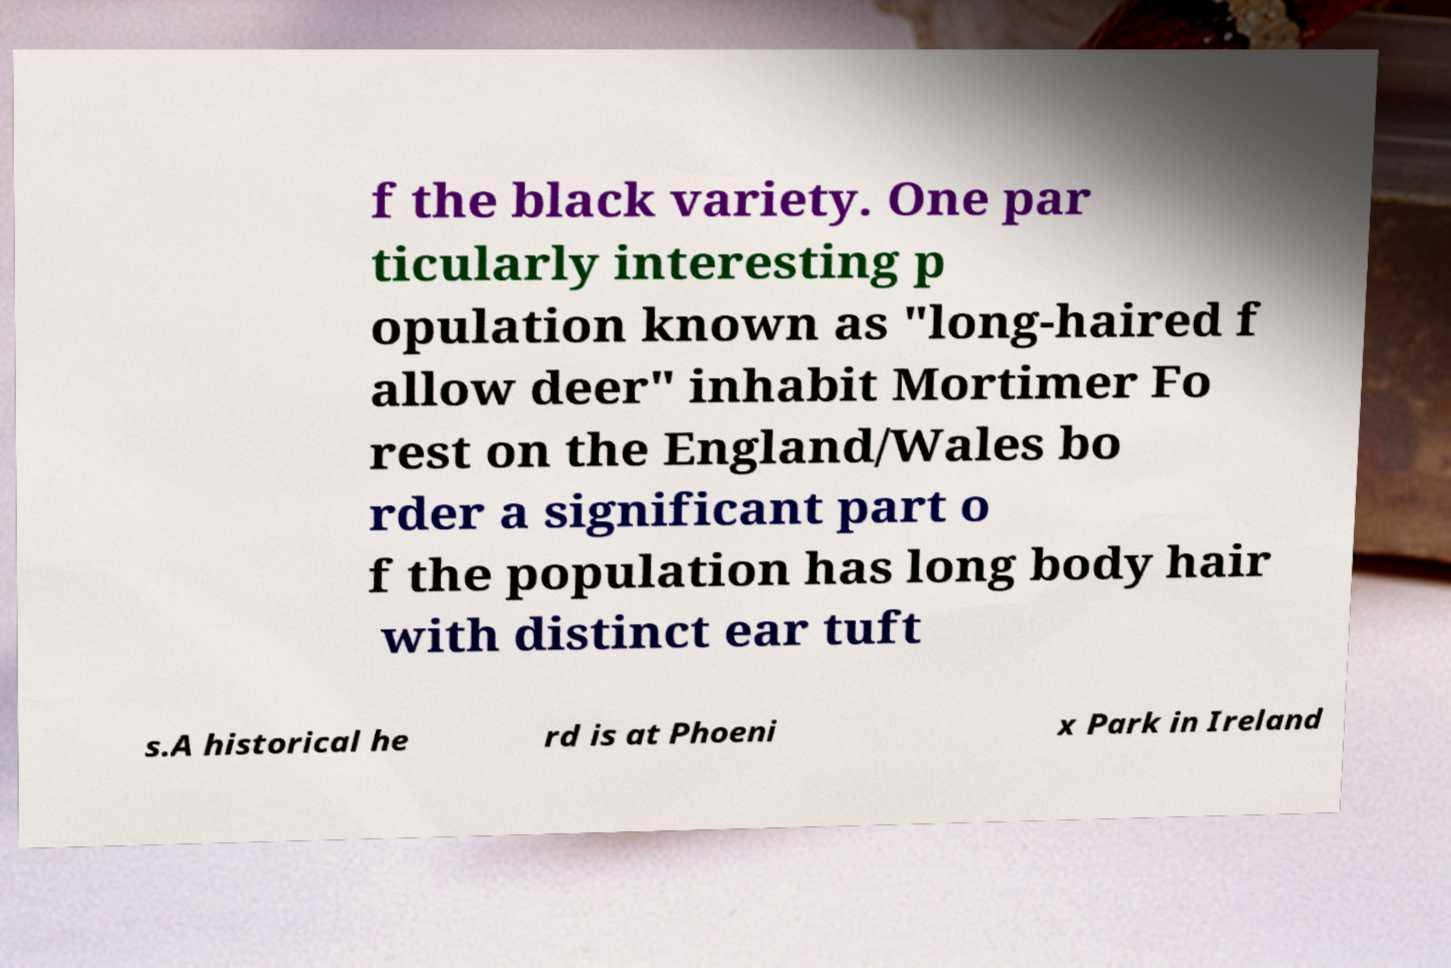Can you read and provide the text displayed in the image?This photo seems to have some interesting text. Can you extract and type it out for me? f the black variety. One par ticularly interesting p opulation known as "long-haired f allow deer" inhabit Mortimer Fo rest on the England/Wales bo rder a significant part o f the population has long body hair with distinct ear tuft s.A historical he rd is at Phoeni x Park in Ireland 